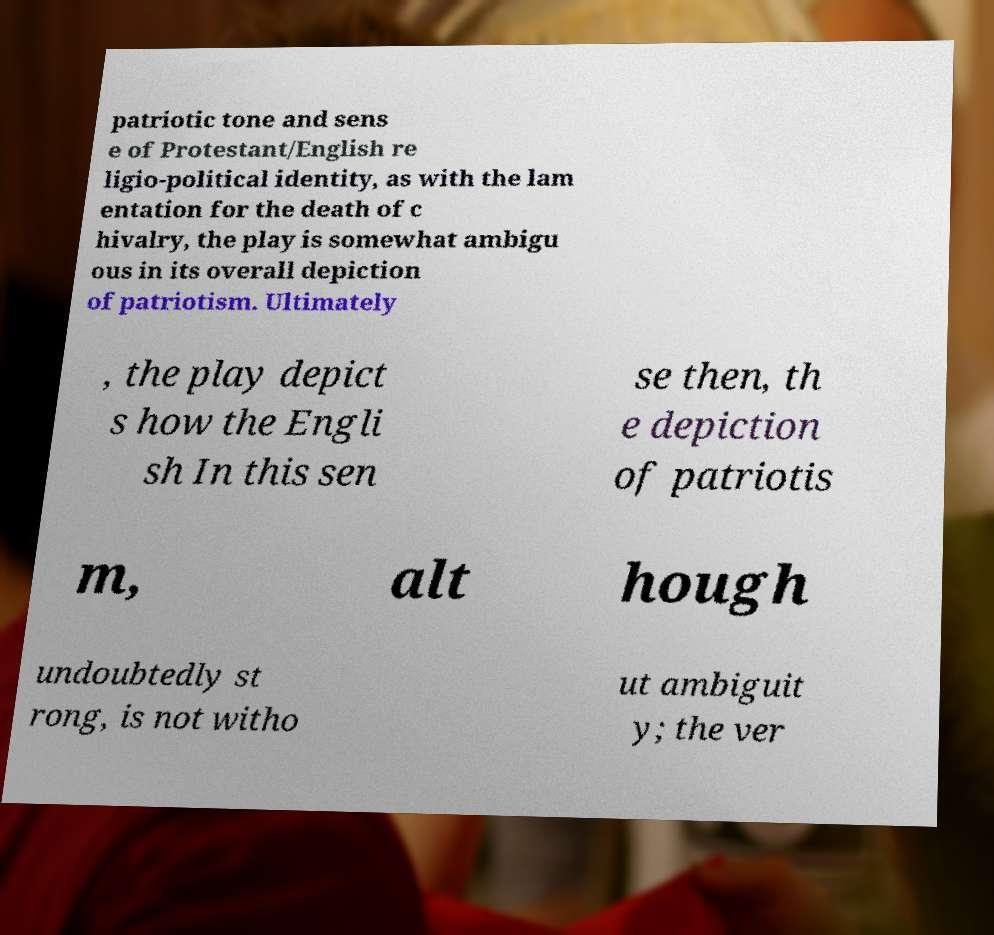Can you read and provide the text displayed in the image?This photo seems to have some interesting text. Can you extract and type it out for me? patriotic tone and sens e of Protestant/English re ligio-political identity, as with the lam entation for the death of c hivalry, the play is somewhat ambigu ous in its overall depiction of patriotism. Ultimately , the play depict s how the Engli sh In this sen se then, th e depiction of patriotis m, alt hough undoubtedly st rong, is not witho ut ambiguit y; the ver 